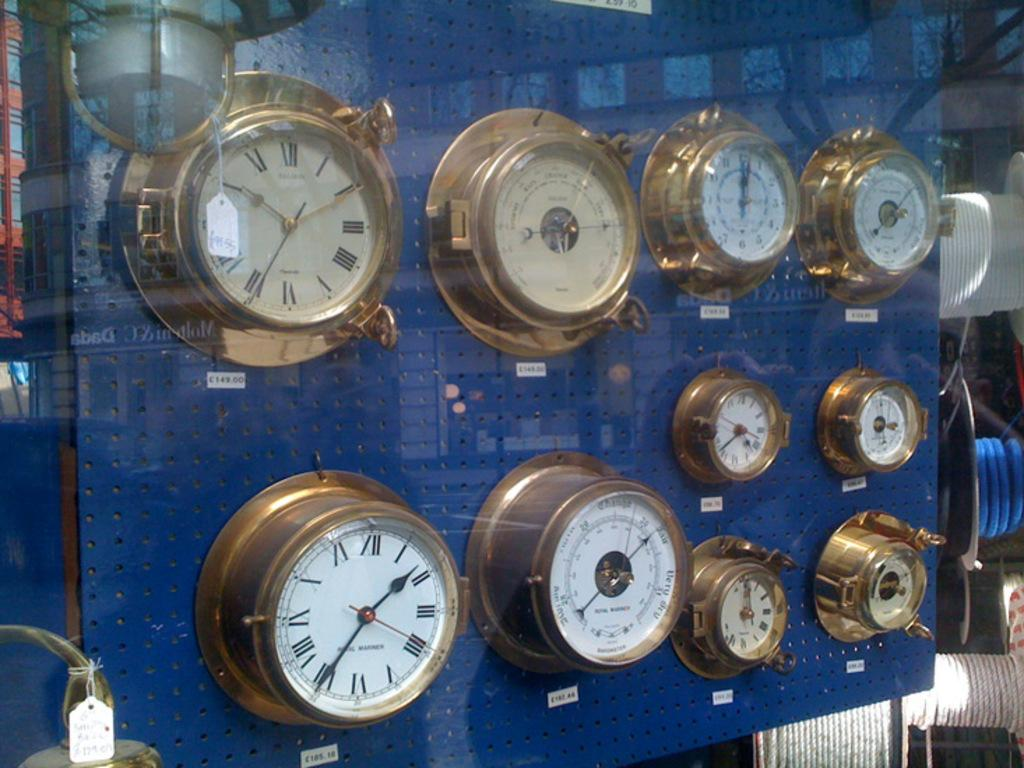<image>
Render a clear and concise summary of the photo. A wall of clocks sits against a blue backdrop with one clock pointing to the numbers 2 and 10 